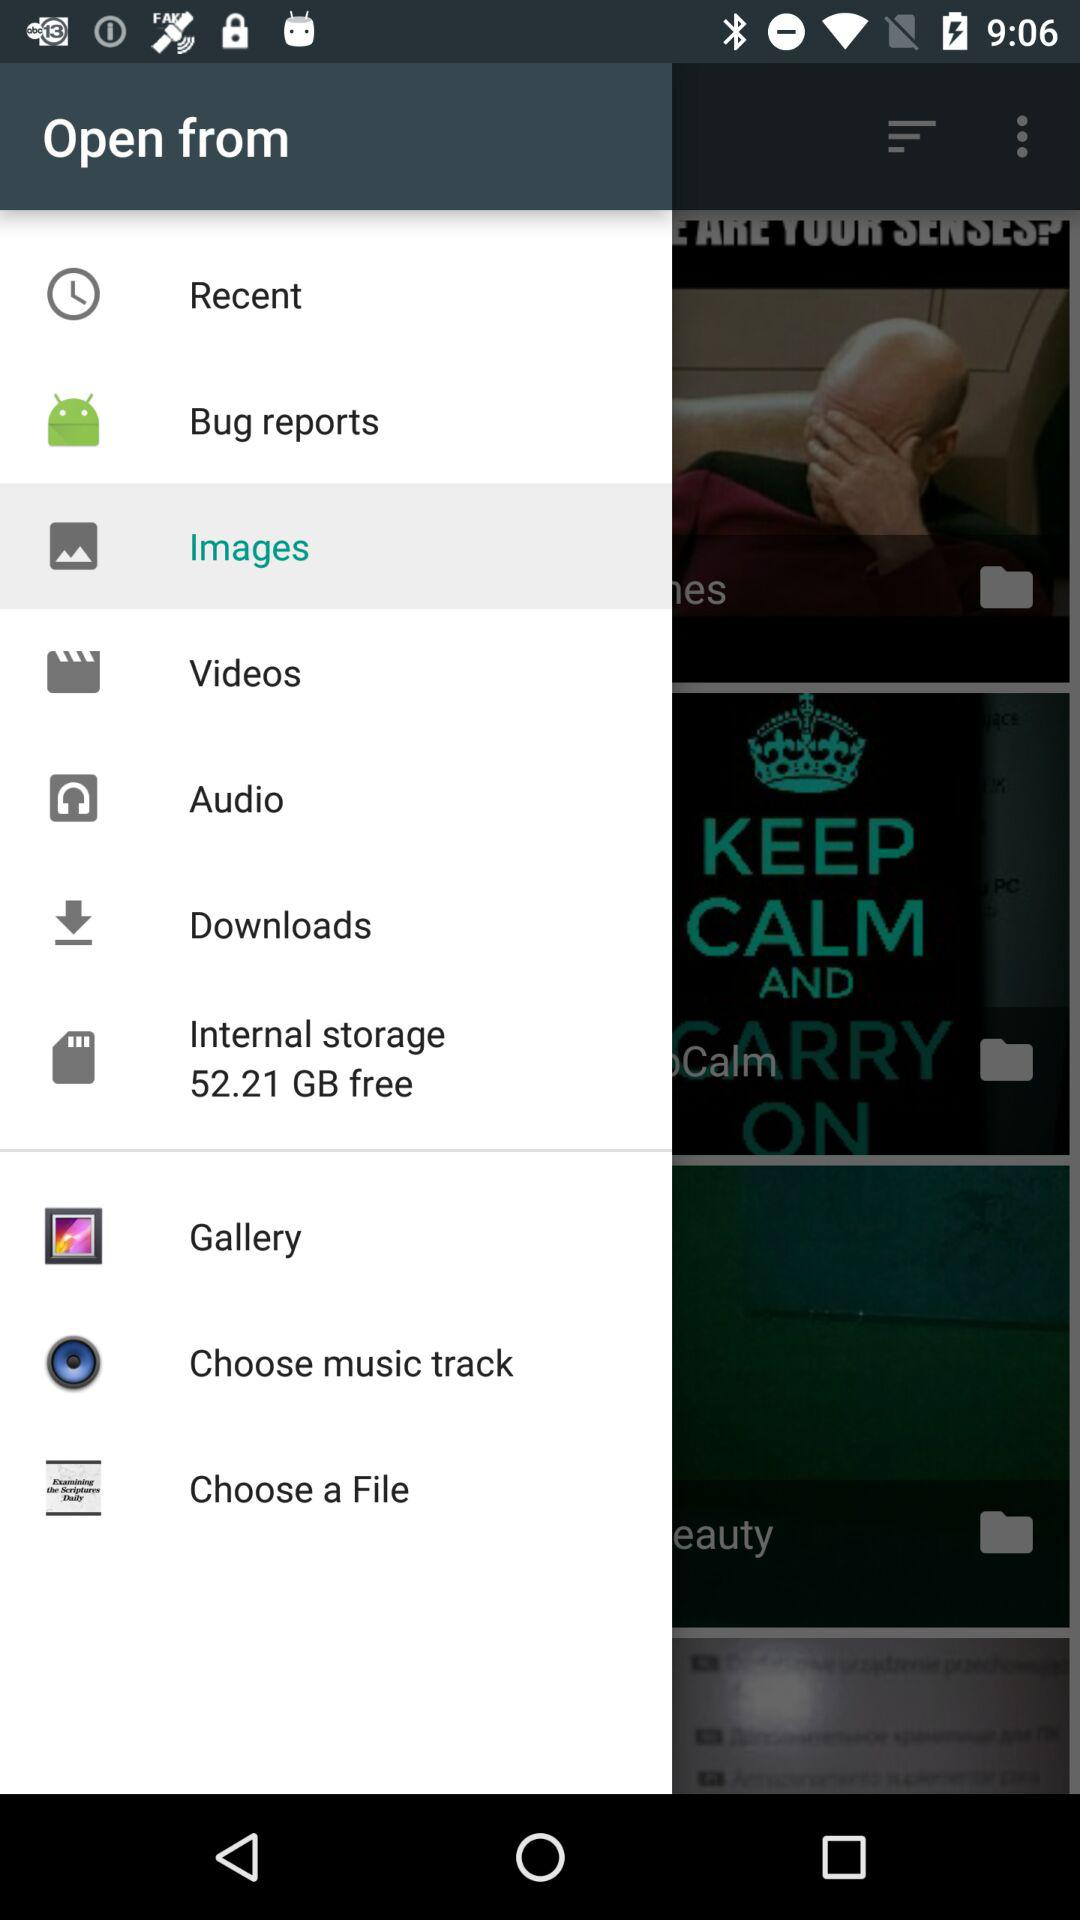What is the selected option? The selected option is "Images". 